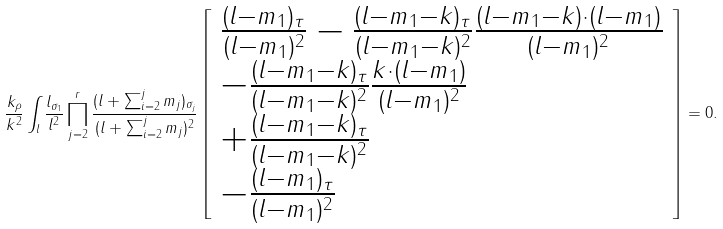<formula> <loc_0><loc_0><loc_500><loc_500>\frac { k _ { \rho } } { k ^ { 2 } } \int _ { l } \frac { l _ { \sigma _ { 1 } } } { l ^ { 2 } } \prod _ { j = 2 } ^ { r } \frac { ( l + \sum _ { i = 2 } ^ { j } m _ { j } ) _ { \sigma _ { j } } } { ( l + \sum _ { i = 2 } ^ { j } m _ { j } ) ^ { 2 } } \left [ \begin{array} { l } \frac { ( l - m _ { 1 } ) _ { \tau } } { ( l - m _ { 1 } ) ^ { 2 } } - \frac { ( l - m _ { 1 } - k ) _ { \tau } } { ( l - m _ { 1 } - k ) ^ { 2 } } \frac { ( l - m _ { 1 } - k ) \cdot ( l - m _ { 1 } ) } { ( l - m _ { 1 } ) ^ { 2 } } \\ - \frac { ( l - m _ { 1 } - k ) _ { \tau } } { ( l - m _ { 1 } - k ) ^ { 2 } } \frac { k \cdot ( l - m _ { 1 } ) } { ( l - m _ { 1 } ) ^ { 2 } } \\ + \frac { ( l - m _ { 1 } - k ) _ { \tau } } { ( l - m _ { 1 } - k ) ^ { 2 } } \\ - \frac { ( l - m _ { 1 } ) _ { \tau } } { ( l - m _ { 1 } ) ^ { 2 } } \end{array} \right ] = 0 .</formula> 